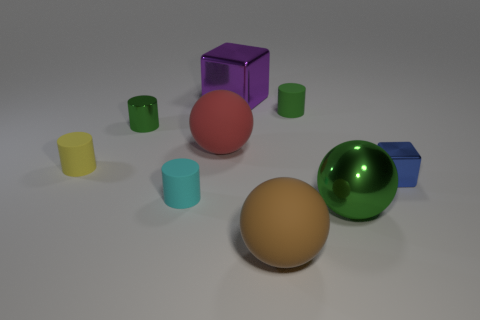Are there any other things that are the same size as the yellow rubber object? Yes, the purple cube and the green sphere appear to be roughly the same size as the yellow cylinder. 